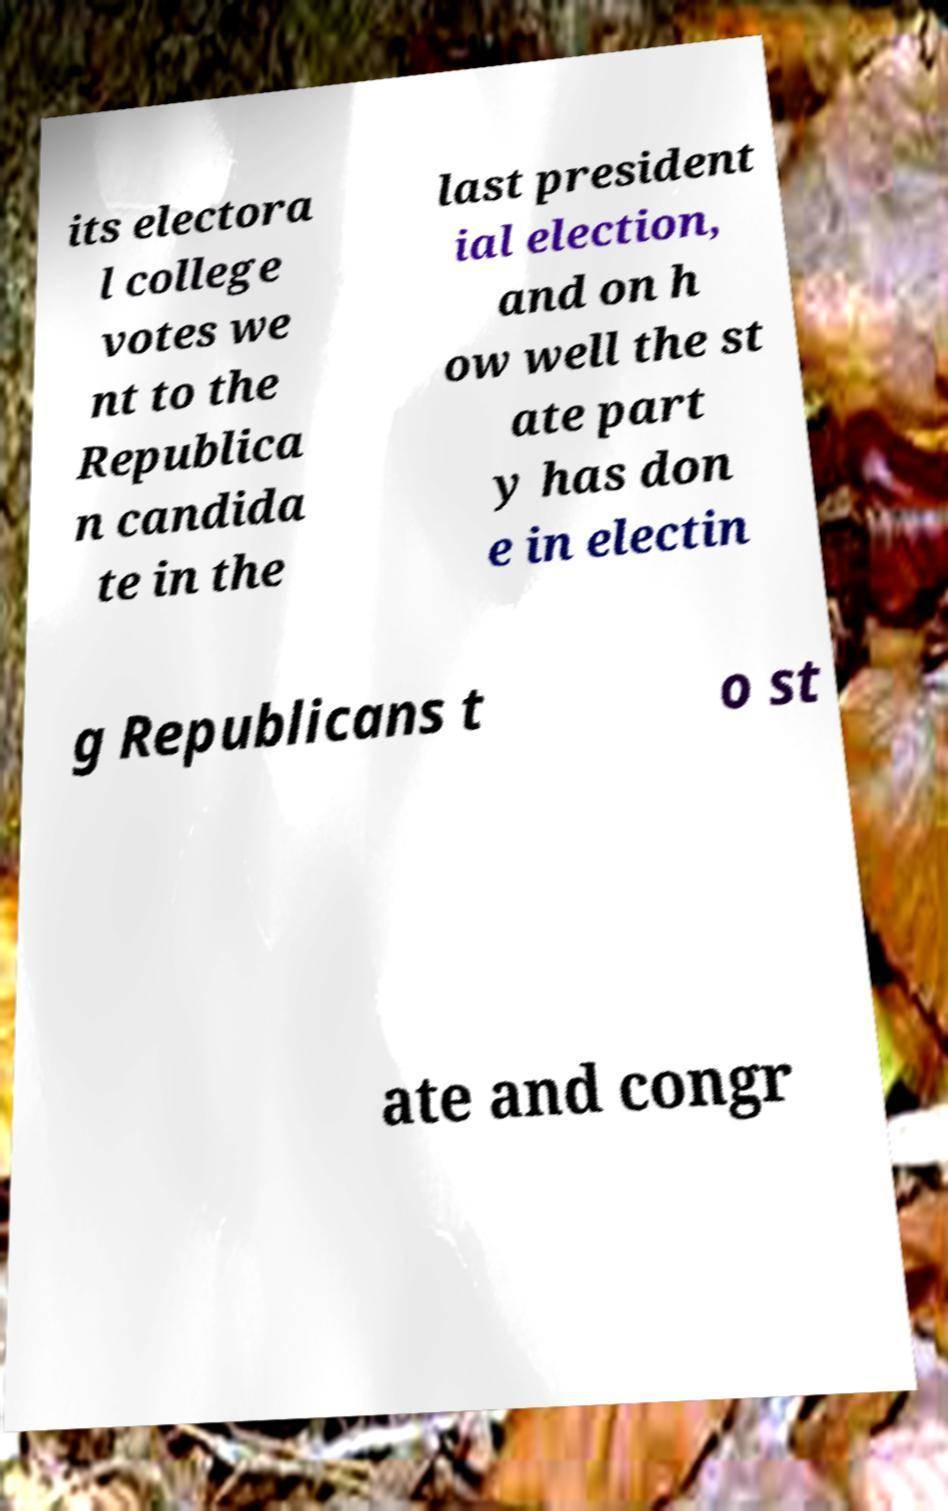Please read and relay the text visible in this image. What does it say? its electora l college votes we nt to the Republica n candida te in the last president ial election, and on h ow well the st ate part y has don e in electin g Republicans t o st ate and congr 